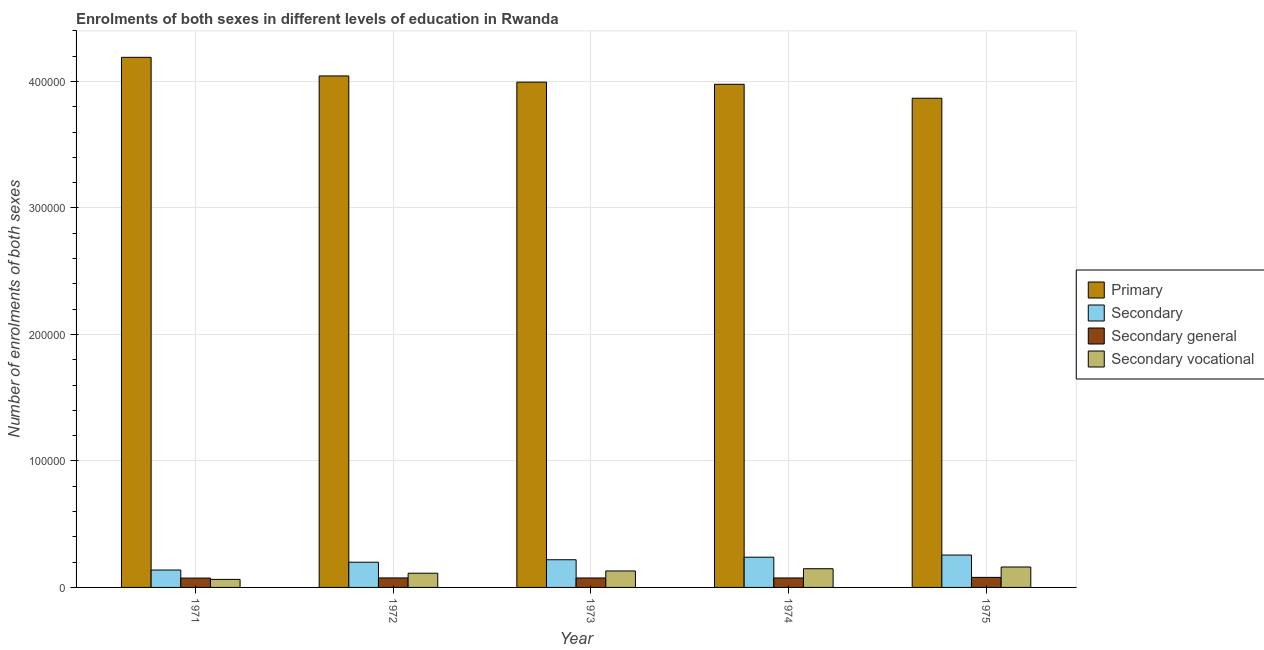How many different coloured bars are there?
Ensure brevity in your answer.  4. Are the number of bars on each tick of the X-axis equal?
Provide a succinct answer. Yes. What is the label of the 4th group of bars from the left?
Your response must be concise. 1974. In how many cases, is the number of bars for a given year not equal to the number of legend labels?
Keep it short and to the point. 0. What is the number of enrolments in primary education in 1973?
Provide a succinct answer. 3.99e+05. Across all years, what is the maximum number of enrolments in secondary vocational education?
Make the answer very short. 1.62e+04. Across all years, what is the minimum number of enrolments in primary education?
Provide a short and direct response. 3.87e+05. In which year was the number of enrolments in secondary general education maximum?
Give a very brief answer. 1975. What is the total number of enrolments in secondary education in the graph?
Your answer should be very brief. 1.05e+05. What is the difference between the number of enrolments in secondary general education in 1973 and that in 1974?
Offer a very short reply. -20. What is the difference between the number of enrolments in secondary education in 1972 and the number of enrolments in secondary vocational education in 1973?
Offer a very short reply. -1954. What is the average number of enrolments in secondary education per year?
Provide a succinct answer. 2.10e+04. In how many years, is the number of enrolments in secondary general education greater than 380000?
Provide a succinct answer. 0. What is the ratio of the number of enrolments in secondary general education in 1973 to that in 1974?
Your answer should be very brief. 1. Is the number of enrolments in primary education in 1971 less than that in 1972?
Your answer should be very brief. No. Is the difference between the number of enrolments in secondary education in 1971 and 1974 greater than the difference between the number of enrolments in secondary vocational education in 1971 and 1974?
Your answer should be very brief. No. What is the difference between the highest and the second highest number of enrolments in secondary education?
Your response must be concise. 1698. What is the difference between the highest and the lowest number of enrolments in primary education?
Keep it short and to the point. 3.23e+04. Is it the case that in every year, the sum of the number of enrolments in secondary general education and number of enrolments in secondary vocational education is greater than the sum of number of enrolments in secondary education and number of enrolments in primary education?
Give a very brief answer. No. What does the 3rd bar from the left in 1974 represents?
Keep it short and to the point. Secondary general. What does the 3rd bar from the right in 1974 represents?
Provide a short and direct response. Secondary. Is it the case that in every year, the sum of the number of enrolments in primary education and number of enrolments in secondary education is greater than the number of enrolments in secondary general education?
Ensure brevity in your answer.  Yes. How many bars are there?
Offer a terse response. 20. What is the difference between two consecutive major ticks on the Y-axis?
Keep it short and to the point. 1.00e+05. Does the graph contain any zero values?
Your response must be concise. No. Does the graph contain grids?
Ensure brevity in your answer.  Yes. How many legend labels are there?
Ensure brevity in your answer.  4. How are the legend labels stacked?
Offer a terse response. Vertical. What is the title of the graph?
Your response must be concise. Enrolments of both sexes in different levels of education in Rwanda. What is the label or title of the Y-axis?
Your response must be concise. Number of enrolments of both sexes. What is the Number of enrolments of both sexes in Primary in 1971?
Keep it short and to the point. 4.19e+05. What is the Number of enrolments of both sexes in Secondary in 1971?
Provide a short and direct response. 1.38e+04. What is the Number of enrolments of both sexes of Secondary general in 1971?
Ensure brevity in your answer.  7398. What is the Number of enrolments of both sexes in Secondary vocational in 1971?
Keep it short and to the point. 6354. What is the Number of enrolments of both sexes of Primary in 1972?
Make the answer very short. 4.04e+05. What is the Number of enrolments of both sexes of Secondary in 1972?
Offer a terse response. 1.99e+04. What is the Number of enrolments of both sexes of Secondary general in 1972?
Offer a very short reply. 7506. What is the Number of enrolments of both sexes in Secondary vocational in 1972?
Your answer should be very brief. 1.12e+04. What is the Number of enrolments of both sexes of Primary in 1973?
Keep it short and to the point. 3.99e+05. What is the Number of enrolments of both sexes in Secondary in 1973?
Provide a succinct answer. 2.19e+04. What is the Number of enrolments of both sexes of Secondary general in 1973?
Provide a succinct answer. 7468. What is the Number of enrolments of both sexes of Secondary vocational in 1973?
Provide a succinct answer. 1.30e+04. What is the Number of enrolments of both sexes of Primary in 1974?
Ensure brevity in your answer.  3.98e+05. What is the Number of enrolments of both sexes in Secondary in 1974?
Offer a very short reply. 2.39e+04. What is the Number of enrolments of both sexes of Secondary general in 1974?
Your response must be concise. 7488. What is the Number of enrolments of both sexes of Secondary vocational in 1974?
Offer a terse response. 1.48e+04. What is the Number of enrolments of both sexes of Primary in 1975?
Make the answer very short. 3.87e+05. What is the Number of enrolments of both sexes of Secondary in 1975?
Provide a short and direct response. 2.56e+04. What is the Number of enrolments of both sexes of Secondary general in 1975?
Your answer should be compact. 7935. What is the Number of enrolments of both sexes in Secondary vocational in 1975?
Your answer should be very brief. 1.62e+04. Across all years, what is the maximum Number of enrolments of both sexes in Primary?
Your answer should be compact. 4.19e+05. Across all years, what is the maximum Number of enrolments of both sexes of Secondary?
Provide a short and direct response. 2.56e+04. Across all years, what is the maximum Number of enrolments of both sexes of Secondary general?
Your answer should be compact. 7935. Across all years, what is the maximum Number of enrolments of both sexes in Secondary vocational?
Your answer should be very brief. 1.62e+04. Across all years, what is the minimum Number of enrolments of both sexes in Primary?
Your answer should be compact. 3.87e+05. Across all years, what is the minimum Number of enrolments of both sexes of Secondary?
Your answer should be compact. 1.38e+04. Across all years, what is the minimum Number of enrolments of both sexes of Secondary general?
Provide a succinct answer. 7398. Across all years, what is the minimum Number of enrolments of both sexes in Secondary vocational?
Give a very brief answer. 6354. What is the total Number of enrolments of both sexes in Primary in the graph?
Provide a short and direct response. 2.01e+06. What is the total Number of enrolments of both sexes in Secondary in the graph?
Offer a very short reply. 1.05e+05. What is the total Number of enrolments of both sexes of Secondary general in the graph?
Offer a terse response. 3.78e+04. What is the total Number of enrolments of both sexes of Secondary vocational in the graph?
Give a very brief answer. 6.15e+04. What is the difference between the Number of enrolments of both sexes of Primary in 1971 and that in 1972?
Provide a succinct answer. 1.47e+04. What is the difference between the Number of enrolments of both sexes in Secondary in 1971 and that in 1972?
Provide a short and direct response. -6184. What is the difference between the Number of enrolments of both sexes in Secondary general in 1971 and that in 1972?
Your answer should be compact. -108. What is the difference between the Number of enrolments of both sexes of Secondary vocational in 1971 and that in 1972?
Give a very brief answer. -4878. What is the difference between the Number of enrolments of both sexes of Primary in 1971 and that in 1973?
Provide a succinct answer. 1.96e+04. What is the difference between the Number of enrolments of both sexes of Secondary in 1971 and that in 1973?
Ensure brevity in your answer.  -8138. What is the difference between the Number of enrolments of both sexes of Secondary general in 1971 and that in 1973?
Offer a terse response. -70. What is the difference between the Number of enrolments of both sexes in Secondary vocational in 1971 and that in 1973?
Provide a short and direct response. -6666. What is the difference between the Number of enrolments of both sexes of Primary in 1971 and that in 1974?
Offer a very short reply. 2.13e+04. What is the difference between the Number of enrolments of both sexes in Secondary in 1971 and that in 1974?
Your response must be concise. -1.02e+04. What is the difference between the Number of enrolments of both sexes in Secondary general in 1971 and that in 1974?
Offer a very short reply. -90. What is the difference between the Number of enrolments of both sexes in Secondary vocational in 1971 and that in 1974?
Your answer should be very brief. -8427. What is the difference between the Number of enrolments of both sexes in Primary in 1971 and that in 1975?
Offer a terse response. 3.23e+04. What is the difference between the Number of enrolments of both sexes in Secondary in 1971 and that in 1975?
Your response must be concise. -1.18e+04. What is the difference between the Number of enrolments of both sexes of Secondary general in 1971 and that in 1975?
Offer a terse response. -537. What is the difference between the Number of enrolments of both sexes of Secondary vocational in 1971 and that in 1975?
Keep it short and to the point. -9796. What is the difference between the Number of enrolments of both sexes of Primary in 1972 and that in 1973?
Offer a very short reply. 4907. What is the difference between the Number of enrolments of both sexes of Secondary in 1972 and that in 1973?
Ensure brevity in your answer.  -1954. What is the difference between the Number of enrolments of both sexes of Secondary general in 1972 and that in 1973?
Offer a very short reply. 38. What is the difference between the Number of enrolments of both sexes in Secondary vocational in 1972 and that in 1973?
Your response must be concise. -1788. What is the difference between the Number of enrolments of both sexes in Primary in 1972 and that in 1974?
Ensure brevity in your answer.  6605. What is the difference between the Number of enrolments of both sexes of Secondary in 1972 and that in 1974?
Provide a short and direct response. -3967. What is the difference between the Number of enrolments of both sexes of Secondary vocational in 1972 and that in 1974?
Your answer should be compact. -3549. What is the difference between the Number of enrolments of both sexes of Primary in 1972 and that in 1975?
Give a very brief answer. 1.76e+04. What is the difference between the Number of enrolments of both sexes in Secondary in 1972 and that in 1975?
Provide a succinct answer. -5665. What is the difference between the Number of enrolments of both sexes of Secondary general in 1972 and that in 1975?
Make the answer very short. -429. What is the difference between the Number of enrolments of both sexes in Secondary vocational in 1972 and that in 1975?
Your answer should be very brief. -4918. What is the difference between the Number of enrolments of both sexes of Primary in 1973 and that in 1974?
Your answer should be very brief. 1698. What is the difference between the Number of enrolments of both sexes of Secondary in 1973 and that in 1974?
Offer a terse response. -2013. What is the difference between the Number of enrolments of both sexes in Secondary general in 1973 and that in 1974?
Your answer should be compact. -20. What is the difference between the Number of enrolments of both sexes of Secondary vocational in 1973 and that in 1974?
Ensure brevity in your answer.  -1761. What is the difference between the Number of enrolments of both sexes of Primary in 1973 and that in 1975?
Keep it short and to the point. 1.27e+04. What is the difference between the Number of enrolments of both sexes in Secondary in 1973 and that in 1975?
Provide a succinct answer. -3711. What is the difference between the Number of enrolments of both sexes of Secondary general in 1973 and that in 1975?
Your answer should be compact. -467. What is the difference between the Number of enrolments of both sexes of Secondary vocational in 1973 and that in 1975?
Provide a short and direct response. -3130. What is the difference between the Number of enrolments of both sexes of Primary in 1974 and that in 1975?
Keep it short and to the point. 1.10e+04. What is the difference between the Number of enrolments of both sexes in Secondary in 1974 and that in 1975?
Provide a short and direct response. -1698. What is the difference between the Number of enrolments of both sexes in Secondary general in 1974 and that in 1975?
Provide a short and direct response. -447. What is the difference between the Number of enrolments of both sexes in Secondary vocational in 1974 and that in 1975?
Keep it short and to the point. -1369. What is the difference between the Number of enrolments of both sexes in Primary in 1971 and the Number of enrolments of both sexes in Secondary in 1972?
Offer a very short reply. 3.99e+05. What is the difference between the Number of enrolments of both sexes in Primary in 1971 and the Number of enrolments of both sexes in Secondary general in 1972?
Offer a terse response. 4.12e+05. What is the difference between the Number of enrolments of both sexes in Primary in 1971 and the Number of enrolments of both sexes in Secondary vocational in 1972?
Offer a terse response. 4.08e+05. What is the difference between the Number of enrolments of both sexes of Secondary in 1971 and the Number of enrolments of both sexes of Secondary general in 1972?
Keep it short and to the point. 6246. What is the difference between the Number of enrolments of both sexes in Secondary in 1971 and the Number of enrolments of both sexes in Secondary vocational in 1972?
Keep it short and to the point. 2520. What is the difference between the Number of enrolments of both sexes of Secondary general in 1971 and the Number of enrolments of both sexes of Secondary vocational in 1972?
Make the answer very short. -3834. What is the difference between the Number of enrolments of both sexes in Primary in 1971 and the Number of enrolments of both sexes in Secondary in 1973?
Keep it short and to the point. 3.97e+05. What is the difference between the Number of enrolments of both sexes of Primary in 1971 and the Number of enrolments of both sexes of Secondary general in 1973?
Your answer should be very brief. 4.12e+05. What is the difference between the Number of enrolments of both sexes of Primary in 1971 and the Number of enrolments of both sexes of Secondary vocational in 1973?
Your answer should be compact. 4.06e+05. What is the difference between the Number of enrolments of both sexes of Secondary in 1971 and the Number of enrolments of both sexes of Secondary general in 1973?
Your answer should be compact. 6284. What is the difference between the Number of enrolments of both sexes in Secondary in 1971 and the Number of enrolments of both sexes in Secondary vocational in 1973?
Ensure brevity in your answer.  732. What is the difference between the Number of enrolments of both sexes in Secondary general in 1971 and the Number of enrolments of both sexes in Secondary vocational in 1973?
Provide a succinct answer. -5622. What is the difference between the Number of enrolments of both sexes of Primary in 1971 and the Number of enrolments of both sexes of Secondary in 1974?
Ensure brevity in your answer.  3.95e+05. What is the difference between the Number of enrolments of both sexes of Primary in 1971 and the Number of enrolments of both sexes of Secondary general in 1974?
Make the answer very short. 4.12e+05. What is the difference between the Number of enrolments of both sexes in Primary in 1971 and the Number of enrolments of both sexes in Secondary vocational in 1974?
Offer a very short reply. 4.04e+05. What is the difference between the Number of enrolments of both sexes of Secondary in 1971 and the Number of enrolments of both sexes of Secondary general in 1974?
Make the answer very short. 6264. What is the difference between the Number of enrolments of both sexes of Secondary in 1971 and the Number of enrolments of both sexes of Secondary vocational in 1974?
Your answer should be compact. -1029. What is the difference between the Number of enrolments of both sexes of Secondary general in 1971 and the Number of enrolments of both sexes of Secondary vocational in 1974?
Your answer should be very brief. -7383. What is the difference between the Number of enrolments of both sexes in Primary in 1971 and the Number of enrolments of both sexes in Secondary in 1975?
Offer a very short reply. 3.93e+05. What is the difference between the Number of enrolments of both sexes of Primary in 1971 and the Number of enrolments of both sexes of Secondary general in 1975?
Your answer should be very brief. 4.11e+05. What is the difference between the Number of enrolments of both sexes of Primary in 1971 and the Number of enrolments of both sexes of Secondary vocational in 1975?
Your answer should be very brief. 4.03e+05. What is the difference between the Number of enrolments of both sexes of Secondary in 1971 and the Number of enrolments of both sexes of Secondary general in 1975?
Provide a succinct answer. 5817. What is the difference between the Number of enrolments of both sexes of Secondary in 1971 and the Number of enrolments of both sexes of Secondary vocational in 1975?
Give a very brief answer. -2398. What is the difference between the Number of enrolments of both sexes in Secondary general in 1971 and the Number of enrolments of both sexes in Secondary vocational in 1975?
Give a very brief answer. -8752. What is the difference between the Number of enrolments of both sexes in Primary in 1972 and the Number of enrolments of both sexes in Secondary in 1973?
Provide a short and direct response. 3.82e+05. What is the difference between the Number of enrolments of both sexes of Primary in 1972 and the Number of enrolments of both sexes of Secondary general in 1973?
Your answer should be very brief. 3.97e+05. What is the difference between the Number of enrolments of both sexes in Primary in 1972 and the Number of enrolments of both sexes in Secondary vocational in 1973?
Ensure brevity in your answer.  3.91e+05. What is the difference between the Number of enrolments of both sexes of Secondary in 1972 and the Number of enrolments of both sexes of Secondary general in 1973?
Your answer should be very brief. 1.25e+04. What is the difference between the Number of enrolments of both sexes of Secondary in 1972 and the Number of enrolments of both sexes of Secondary vocational in 1973?
Ensure brevity in your answer.  6916. What is the difference between the Number of enrolments of both sexes in Secondary general in 1972 and the Number of enrolments of both sexes in Secondary vocational in 1973?
Make the answer very short. -5514. What is the difference between the Number of enrolments of both sexes of Primary in 1972 and the Number of enrolments of both sexes of Secondary in 1974?
Your answer should be very brief. 3.80e+05. What is the difference between the Number of enrolments of both sexes of Primary in 1972 and the Number of enrolments of both sexes of Secondary general in 1974?
Keep it short and to the point. 3.97e+05. What is the difference between the Number of enrolments of both sexes in Primary in 1972 and the Number of enrolments of both sexes in Secondary vocational in 1974?
Your answer should be compact. 3.90e+05. What is the difference between the Number of enrolments of both sexes in Secondary in 1972 and the Number of enrolments of both sexes in Secondary general in 1974?
Keep it short and to the point. 1.24e+04. What is the difference between the Number of enrolments of both sexes of Secondary in 1972 and the Number of enrolments of both sexes of Secondary vocational in 1974?
Offer a terse response. 5155. What is the difference between the Number of enrolments of both sexes in Secondary general in 1972 and the Number of enrolments of both sexes in Secondary vocational in 1974?
Offer a terse response. -7275. What is the difference between the Number of enrolments of both sexes in Primary in 1972 and the Number of enrolments of both sexes in Secondary in 1975?
Your answer should be compact. 3.79e+05. What is the difference between the Number of enrolments of both sexes of Primary in 1972 and the Number of enrolments of both sexes of Secondary general in 1975?
Give a very brief answer. 3.96e+05. What is the difference between the Number of enrolments of both sexes of Primary in 1972 and the Number of enrolments of both sexes of Secondary vocational in 1975?
Keep it short and to the point. 3.88e+05. What is the difference between the Number of enrolments of both sexes of Secondary in 1972 and the Number of enrolments of both sexes of Secondary general in 1975?
Ensure brevity in your answer.  1.20e+04. What is the difference between the Number of enrolments of both sexes in Secondary in 1972 and the Number of enrolments of both sexes in Secondary vocational in 1975?
Your response must be concise. 3786. What is the difference between the Number of enrolments of both sexes in Secondary general in 1972 and the Number of enrolments of both sexes in Secondary vocational in 1975?
Offer a terse response. -8644. What is the difference between the Number of enrolments of both sexes in Primary in 1973 and the Number of enrolments of both sexes in Secondary in 1974?
Ensure brevity in your answer.  3.76e+05. What is the difference between the Number of enrolments of both sexes in Primary in 1973 and the Number of enrolments of both sexes in Secondary general in 1974?
Keep it short and to the point. 3.92e+05. What is the difference between the Number of enrolments of both sexes in Primary in 1973 and the Number of enrolments of both sexes in Secondary vocational in 1974?
Offer a very short reply. 3.85e+05. What is the difference between the Number of enrolments of both sexes in Secondary in 1973 and the Number of enrolments of both sexes in Secondary general in 1974?
Offer a terse response. 1.44e+04. What is the difference between the Number of enrolments of both sexes in Secondary in 1973 and the Number of enrolments of both sexes in Secondary vocational in 1974?
Provide a succinct answer. 7109. What is the difference between the Number of enrolments of both sexes in Secondary general in 1973 and the Number of enrolments of both sexes in Secondary vocational in 1974?
Provide a short and direct response. -7313. What is the difference between the Number of enrolments of both sexes in Primary in 1973 and the Number of enrolments of both sexes in Secondary in 1975?
Your response must be concise. 3.74e+05. What is the difference between the Number of enrolments of both sexes of Primary in 1973 and the Number of enrolments of both sexes of Secondary general in 1975?
Your answer should be very brief. 3.92e+05. What is the difference between the Number of enrolments of both sexes of Primary in 1973 and the Number of enrolments of both sexes of Secondary vocational in 1975?
Offer a very short reply. 3.83e+05. What is the difference between the Number of enrolments of both sexes of Secondary in 1973 and the Number of enrolments of both sexes of Secondary general in 1975?
Ensure brevity in your answer.  1.40e+04. What is the difference between the Number of enrolments of both sexes of Secondary in 1973 and the Number of enrolments of both sexes of Secondary vocational in 1975?
Provide a succinct answer. 5740. What is the difference between the Number of enrolments of both sexes in Secondary general in 1973 and the Number of enrolments of both sexes in Secondary vocational in 1975?
Provide a succinct answer. -8682. What is the difference between the Number of enrolments of both sexes of Primary in 1974 and the Number of enrolments of both sexes of Secondary in 1975?
Provide a succinct answer. 3.72e+05. What is the difference between the Number of enrolments of both sexes in Primary in 1974 and the Number of enrolments of both sexes in Secondary general in 1975?
Offer a very short reply. 3.90e+05. What is the difference between the Number of enrolments of both sexes of Primary in 1974 and the Number of enrolments of both sexes of Secondary vocational in 1975?
Give a very brief answer. 3.82e+05. What is the difference between the Number of enrolments of both sexes of Secondary in 1974 and the Number of enrolments of both sexes of Secondary general in 1975?
Make the answer very short. 1.60e+04. What is the difference between the Number of enrolments of both sexes in Secondary in 1974 and the Number of enrolments of both sexes in Secondary vocational in 1975?
Provide a short and direct response. 7753. What is the difference between the Number of enrolments of both sexes in Secondary general in 1974 and the Number of enrolments of both sexes in Secondary vocational in 1975?
Provide a short and direct response. -8662. What is the average Number of enrolments of both sexes in Primary per year?
Your response must be concise. 4.01e+05. What is the average Number of enrolments of both sexes of Secondary per year?
Provide a succinct answer. 2.10e+04. What is the average Number of enrolments of both sexes of Secondary general per year?
Provide a short and direct response. 7559. What is the average Number of enrolments of both sexes of Secondary vocational per year?
Provide a short and direct response. 1.23e+04. In the year 1971, what is the difference between the Number of enrolments of both sexes of Primary and Number of enrolments of both sexes of Secondary?
Your answer should be compact. 4.05e+05. In the year 1971, what is the difference between the Number of enrolments of both sexes in Primary and Number of enrolments of both sexes in Secondary general?
Ensure brevity in your answer.  4.12e+05. In the year 1971, what is the difference between the Number of enrolments of both sexes in Primary and Number of enrolments of both sexes in Secondary vocational?
Give a very brief answer. 4.13e+05. In the year 1971, what is the difference between the Number of enrolments of both sexes in Secondary and Number of enrolments of both sexes in Secondary general?
Keep it short and to the point. 6354. In the year 1971, what is the difference between the Number of enrolments of both sexes of Secondary and Number of enrolments of both sexes of Secondary vocational?
Your answer should be very brief. 7398. In the year 1971, what is the difference between the Number of enrolments of both sexes of Secondary general and Number of enrolments of both sexes of Secondary vocational?
Provide a short and direct response. 1044. In the year 1972, what is the difference between the Number of enrolments of both sexes in Primary and Number of enrolments of both sexes in Secondary?
Keep it short and to the point. 3.84e+05. In the year 1972, what is the difference between the Number of enrolments of both sexes in Primary and Number of enrolments of both sexes in Secondary general?
Your answer should be compact. 3.97e+05. In the year 1972, what is the difference between the Number of enrolments of both sexes of Primary and Number of enrolments of both sexes of Secondary vocational?
Keep it short and to the point. 3.93e+05. In the year 1972, what is the difference between the Number of enrolments of both sexes of Secondary and Number of enrolments of both sexes of Secondary general?
Your answer should be very brief. 1.24e+04. In the year 1972, what is the difference between the Number of enrolments of both sexes of Secondary and Number of enrolments of both sexes of Secondary vocational?
Provide a succinct answer. 8704. In the year 1972, what is the difference between the Number of enrolments of both sexes of Secondary general and Number of enrolments of both sexes of Secondary vocational?
Your response must be concise. -3726. In the year 1973, what is the difference between the Number of enrolments of both sexes of Primary and Number of enrolments of both sexes of Secondary?
Offer a terse response. 3.78e+05. In the year 1973, what is the difference between the Number of enrolments of both sexes in Primary and Number of enrolments of both sexes in Secondary general?
Ensure brevity in your answer.  3.92e+05. In the year 1973, what is the difference between the Number of enrolments of both sexes of Primary and Number of enrolments of both sexes of Secondary vocational?
Provide a short and direct response. 3.86e+05. In the year 1973, what is the difference between the Number of enrolments of both sexes in Secondary and Number of enrolments of both sexes in Secondary general?
Your response must be concise. 1.44e+04. In the year 1973, what is the difference between the Number of enrolments of both sexes of Secondary and Number of enrolments of both sexes of Secondary vocational?
Provide a short and direct response. 8870. In the year 1973, what is the difference between the Number of enrolments of both sexes in Secondary general and Number of enrolments of both sexes in Secondary vocational?
Make the answer very short. -5552. In the year 1974, what is the difference between the Number of enrolments of both sexes of Primary and Number of enrolments of both sexes of Secondary?
Ensure brevity in your answer.  3.74e+05. In the year 1974, what is the difference between the Number of enrolments of both sexes of Primary and Number of enrolments of both sexes of Secondary general?
Offer a terse response. 3.90e+05. In the year 1974, what is the difference between the Number of enrolments of both sexes of Primary and Number of enrolments of both sexes of Secondary vocational?
Provide a short and direct response. 3.83e+05. In the year 1974, what is the difference between the Number of enrolments of both sexes of Secondary and Number of enrolments of both sexes of Secondary general?
Provide a short and direct response. 1.64e+04. In the year 1974, what is the difference between the Number of enrolments of both sexes of Secondary and Number of enrolments of both sexes of Secondary vocational?
Keep it short and to the point. 9122. In the year 1974, what is the difference between the Number of enrolments of both sexes of Secondary general and Number of enrolments of both sexes of Secondary vocational?
Make the answer very short. -7293. In the year 1975, what is the difference between the Number of enrolments of both sexes in Primary and Number of enrolments of both sexes in Secondary?
Make the answer very short. 3.61e+05. In the year 1975, what is the difference between the Number of enrolments of both sexes of Primary and Number of enrolments of both sexes of Secondary general?
Your answer should be compact. 3.79e+05. In the year 1975, what is the difference between the Number of enrolments of both sexes in Primary and Number of enrolments of both sexes in Secondary vocational?
Provide a short and direct response. 3.71e+05. In the year 1975, what is the difference between the Number of enrolments of both sexes of Secondary and Number of enrolments of both sexes of Secondary general?
Keep it short and to the point. 1.77e+04. In the year 1975, what is the difference between the Number of enrolments of both sexes in Secondary and Number of enrolments of both sexes in Secondary vocational?
Keep it short and to the point. 9451. In the year 1975, what is the difference between the Number of enrolments of both sexes in Secondary general and Number of enrolments of both sexes in Secondary vocational?
Your answer should be compact. -8215. What is the ratio of the Number of enrolments of both sexes of Primary in 1971 to that in 1972?
Provide a short and direct response. 1.04. What is the ratio of the Number of enrolments of both sexes of Secondary in 1971 to that in 1972?
Make the answer very short. 0.69. What is the ratio of the Number of enrolments of both sexes in Secondary general in 1971 to that in 1972?
Your answer should be very brief. 0.99. What is the ratio of the Number of enrolments of both sexes in Secondary vocational in 1971 to that in 1972?
Provide a short and direct response. 0.57. What is the ratio of the Number of enrolments of both sexes of Primary in 1971 to that in 1973?
Provide a succinct answer. 1.05. What is the ratio of the Number of enrolments of both sexes in Secondary in 1971 to that in 1973?
Provide a short and direct response. 0.63. What is the ratio of the Number of enrolments of both sexes of Secondary general in 1971 to that in 1973?
Keep it short and to the point. 0.99. What is the ratio of the Number of enrolments of both sexes of Secondary vocational in 1971 to that in 1973?
Make the answer very short. 0.49. What is the ratio of the Number of enrolments of both sexes in Primary in 1971 to that in 1974?
Ensure brevity in your answer.  1.05. What is the ratio of the Number of enrolments of both sexes of Secondary in 1971 to that in 1974?
Your response must be concise. 0.58. What is the ratio of the Number of enrolments of both sexes in Secondary general in 1971 to that in 1974?
Offer a very short reply. 0.99. What is the ratio of the Number of enrolments of both sexes in Secondary vocational in 1971 to that in 1974?
Offer a very short reply. 0.43. What is the ratio of the Number of enrolments of both sexes of Primary in 1971 to that in 1975?
Give a very brief answer. 1.08. What is the ratio of the Number of enrolments of both sexes of Secondary in 1971 to that in 1975?
Provide a succinct answer. 0.54. What is the ratio of the Number of enrolments of both sexes of Secondary general in 1971 to that in 1975?
Give a very brief answer. 0.93. What is the ratio of the Number of enrolments of both sexes of Secondary vocational in 1971 to that in 1975?
Provide a short and direct response. 0.39. What is the ratio of the Number of enrolments of both sexes of Primary in 1972 to that in 1973?
Provide a succinct answer. 1.01. What is the ratio of the Number of enrolments of both sexes in Secondary in 1972 to that in 1973?
Make the answer very short. 0.91. What is the ratio of the Number of enrolments of both sexes in Secondary vocational in 1972 to that in 1973?
Give a very brief answer. 0.86. What is the ratio of the Number of enrolments of both sexes in Primary in 1972 to that in 1974?
Ensure brevity in your answer.  1.02. What is the ratio of the Number of enrolments of both sexes of Secondary in 1972 to that in 1974?
Give a very brief answer. 0.83. What is the ratio of the Number of enrolments of both sexes of Secondary general in 1972 to that in 1974?
Give a very brief answer. 1. What is the ratio of the Number of enrolments of both sexes in Secondary vocational in 1972 to that in 1974?
Your response must be concise. 0.76. What is the ratio of the Number of enrolments of both sexes of Primary in 1972 to that in 1975?
Keep it short and to the point. 1.05. What is the ratio of the Number of enrolments of both sexes of Secondary in 1972 to that in 1975?
Keep it short and to the point. 0.78. What is the ratio of the Number of enrolments of both sexes of Secondary general in 1972 to that in 1975?
Ensure brevity in your answer.  0.95. What is the ratio of the Number of enrolments of both sexes of Secondary vocational in 1972 to that in 1975?
Offer a very short reply. 0.7. What is the ratio of the Number of enrolments of both sexes in Secondary in 1973 to that in 1974?
Make the answer very short. 0.92. What is the ratio of the Number of enrolments of both sexes in Secondary vocational in 1973 to that in 1974?
Your answer should be very brief. 0.88. What is the ratio of the Number of enrolments of both sexes of Primary in 1973 to that in 1975?
Give a very brief answer. 1.03. What is the ratio of the Number of enrolments of both sexes of Secondary in 1973 to that in 1975?
Your response must be concise. 0.85. What is the ratio of the Number of enrolments of both sexes of Secondary general in 1973 to that in 1975?
Your response must be concise. 0.94. What is the ratio of the Number of enrolments of both sexes in Secondary vocational in 1973 to that in 1975?
Offer a very short reply. 0.81. What is the ratio of the Number of enrolments of both sexes of Primary in 1974 to that in 1975?
Make the answer very short. 1.03. What is the ratio of the Number of enrolments of both sexes in Secondary in 1974 to that in 1975?
Offer a very short reply. 0.93. What is the ratio of the Number of enrolments of both sexes in Secondary general in 1974 to that in 1975?
Ensure brevity in your answer.  0.94. What is the ratio of the Number of enrolments of both sexes in Secondary vocational in 1974 to that in 1975?
Your response must be concise. 0.92. What is the difference between the highest and the second highest Number of enrolments of both sexes in Primary?
Provide a short and direct response. 1.47e+04. What is the difference between the highest and the second highest Number of enrolments of both sexes in Secondary?
Ensure brevity in your answer.  1698. What is the difference between the highest and the second highest Number of enrolments of both sexes in Secondary general?
Your answer should be very brief. 429. What is the difference between the highest and the second highest Number of enrolments of both sexes of Secondary vocational?
Give a very brief answer. 1369. What is the difference between the highest and the lowest Number of enrolments of both sexes of Primary?
Give a very brief answer. 3.23e+04. What is the difference between the highest and the lowest Number of enrolments of both sexes of Secondary?
Ensure brevity in your answer.  1.18e+04. What is the difference between the highest and the lowest Number of enrolments of both sexes in Secondary general?
Your answer should be very brief. 537. What is the difference between the highest and the lowest Number of enrolments of both sexes of Secondary vocational?
Keep it short and to the point. 9796. 